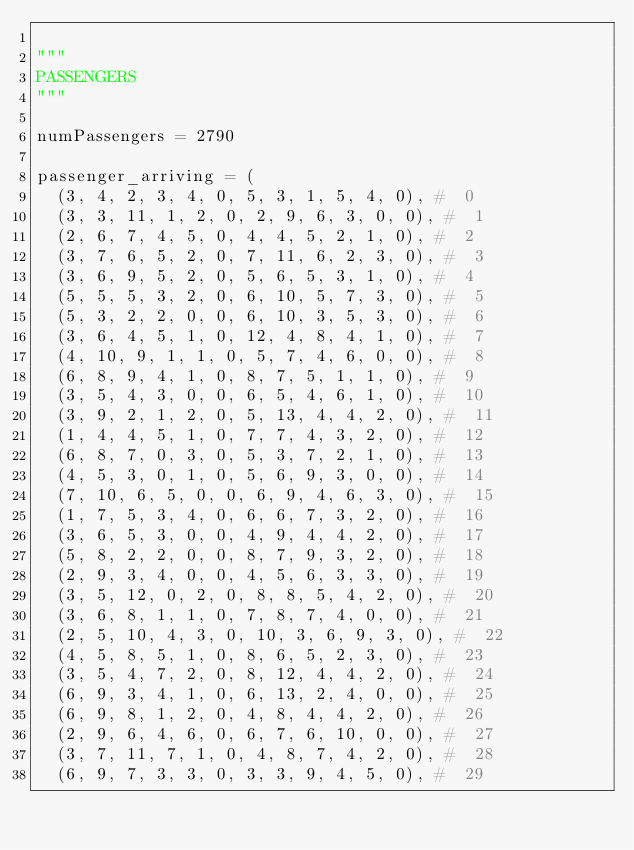Convert code to text. <code><loc_0><loc_0><loc_500><loc_500><_Python_>
"""
PASSENGERS
"""

numPassengers = 2790

passenger_arriving = (
	(3, 4, 2, 3, 4, 0, 5, 3, 1, 5, 4, 0), #  0
	(3, 3, 11, 1, 2, 0, 2, 9, 6, 3, 0, 0), #  1
	(2, 6, 7, 4, 5, 0, 4, 4, 5, 2, 1, 0), #  2
	(3, 7, 6, 5, 2, 0, 7, 11, 6, 2, 3, 0), #  3
	(3, 6, 9, 5, 2, 0, 5, 6, 5, 3, 1, 0), #  4
	(5, 5, 5, 3, 2, 0, 6, 10, 5, 7, 3, 0), #  5
	(5, 3, 2, 2, 0, 0, 6, 10, 3, 5, 3, 0), #  6
	(3, 6, 4, 5, 1, 0, 12, 4, 8, 4, 1, 0), #  7
	(4, 10, 9, 1, 1, 0, 5, 7, 4, 6, 0, 0), #  8
	(6, 8, 9, 4, 1, 0, 8, 7, 5, 1, 1, 0), #  9
	(3, 5, 4, 3, 0, 0, 6, 5, 4, 6, 1, 0), #  10
	(3, 9, 2, 1, 2, 0, 5, 13, 4, 4, 2, 0), #  11
	(1, 4, 4, 5, 1, 0, 7, 7, 4, 3, 2, 0), #  12
	(6, 8, 7, 0, 3, 0, 5, 3, 7, 2, 1, 0), #  13
	(4, 5, 3, 0, 1, 0, 5, 6, 9, 3, 0, 0), #  14
	(7, 10, 6, 5, 0, 0, 6, 9, 4, 6, 3, 0), #  15
	(1, 7, 5, 3, 4, 0, 6, 6, 7, 3, 2, 0), #  16
	(3, 6, 5, 3, 0, 0, 4, 9, 4, 4, 2, 0), #  17
	(5, 8, 2, 2, 0, 0, 8, 7, 9, 3, 2, 0), #  18
	(2, 9, 3, 4, 0, 0, 4, 5, 6, 3, 3, 0), #  19
	(3, 5, 12, 0, 2, 0, 8, 8, 5, 4, 2, 0), #  20
	(3, 6, 8, 1, 1, 0, 7, 8, 7, 4, 0, 0), #  21
	(2, 5, 10, 4, 3, 0, 10, 3, 6, 9, 3, 0), #  22
	(4, 5, 8, 5, 1, 0, 8, 6, 5, 2, 3, 0), #  23
	(3, 5, 4, 7, 2, 0, 8, 12, 4, 4, 2, 0), #  24
	(6, 9, 3, 4, 1, 0, 6, 13, 2, 4, 0, 0), #  25
	(6, 9, 8, 1, 2, 0, 4, 8, 4, 4, 2, 0), #  26
	(2, 9, 6, 4, 6, 0, 6, 7, 6, 10, 0, 0), #  27
	(3, 7, 11, 7, 1, 0, 4, 8, 7, 4, 2, 0), #  28
	(6, 9, 7, 3, 3, 0, 3, 3, 9, 4, 5, 0), #  29</code> 